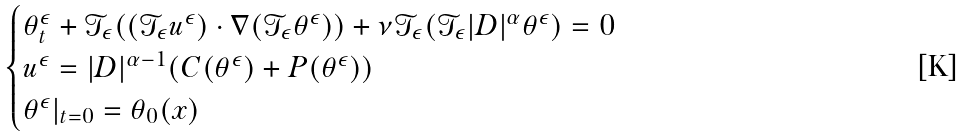<formula> <loc_0><loc_0><loc_500><loc_500>\begin{cases} \theta _ { t } ^ { \epsilon } + \mathcal { T } _ { \epsilon } ( ( \mathcal { T } _ { \epsilon } u ^ { \epsilon } ) \cdot \nabla ( \mathcal { T } _ { \epsilon } \theta ^ { \epsilon } ) ) + \nu \mathcal { T } _ { \epsilon } ( \mathcal { T } _ { \epsilon } | D | ^ { \alpha } \theta ^ { \epsilon } ) = 0 \\ u ^ { \epsilon } = | D | ^ { \alpha - 1 } ( C ( \theta ^ { \epsilon } ) + P ( \theta ^ { \epsilon } ) ) \\ \theta ^ { \epsilon } | _ { t = 0 } = \theta _ { 0 } ( x ) \ \end{cases}</formula> 